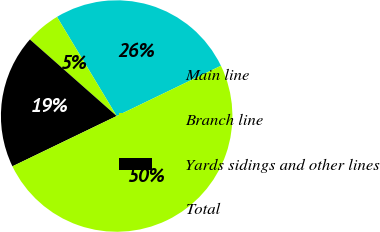Convert chart. <chart><loc_0><loc_0><loc_500><loc_500><pie_chart><fcel>Main line<fcel>Branch line<fcel>Yards sidings and other lines<fcel>Total<nl><fcel>26.47%<fcel>4.87%<fcel>18.66%<fcel>50.0%<nl></chart> 